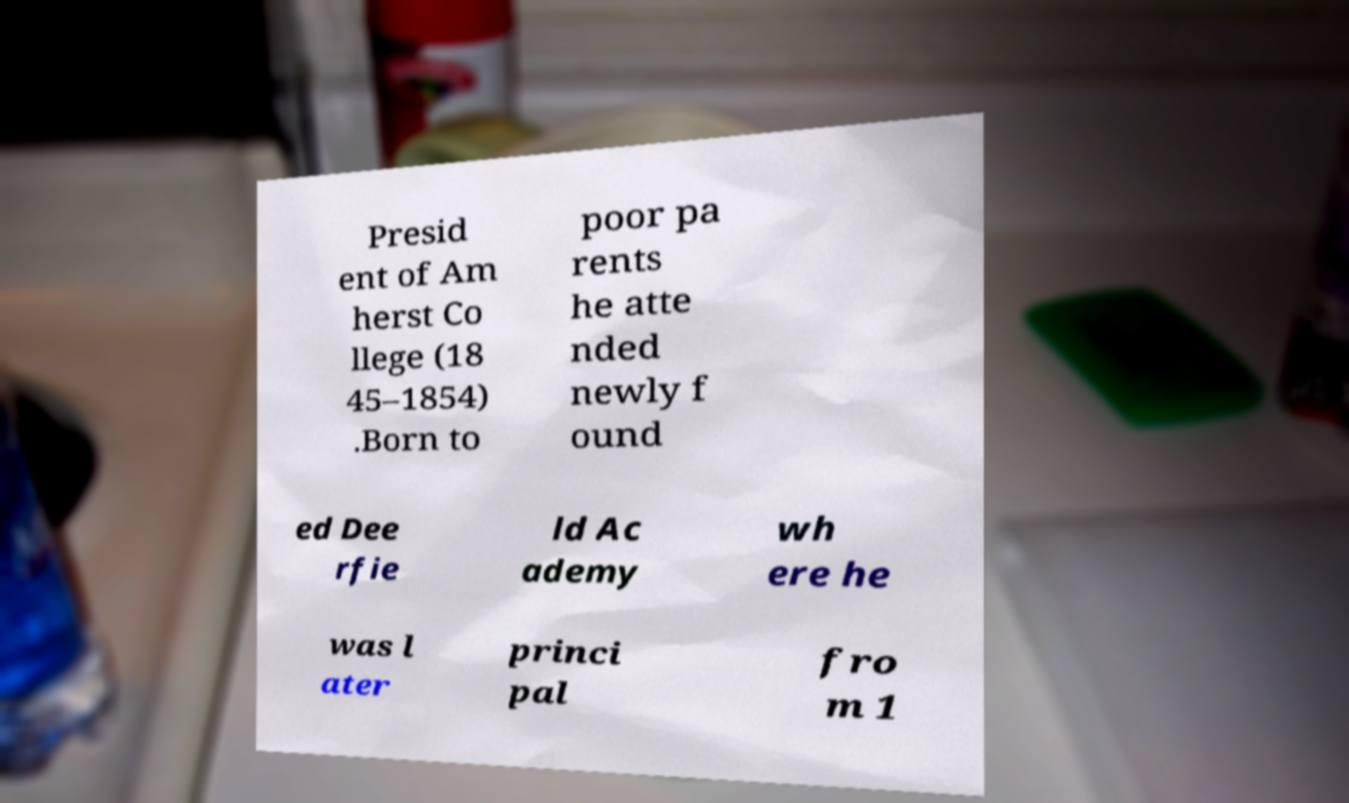For documentation purposes, I need the text within this image transcribed. Could you provide that? Presid ent of Am herst Co llege (18 45–1854) .Born to poor pa rents he atte nded newly f ound ed Dee rfie ld Ac ademy wh ere he was l ater princi pal fro m 1 